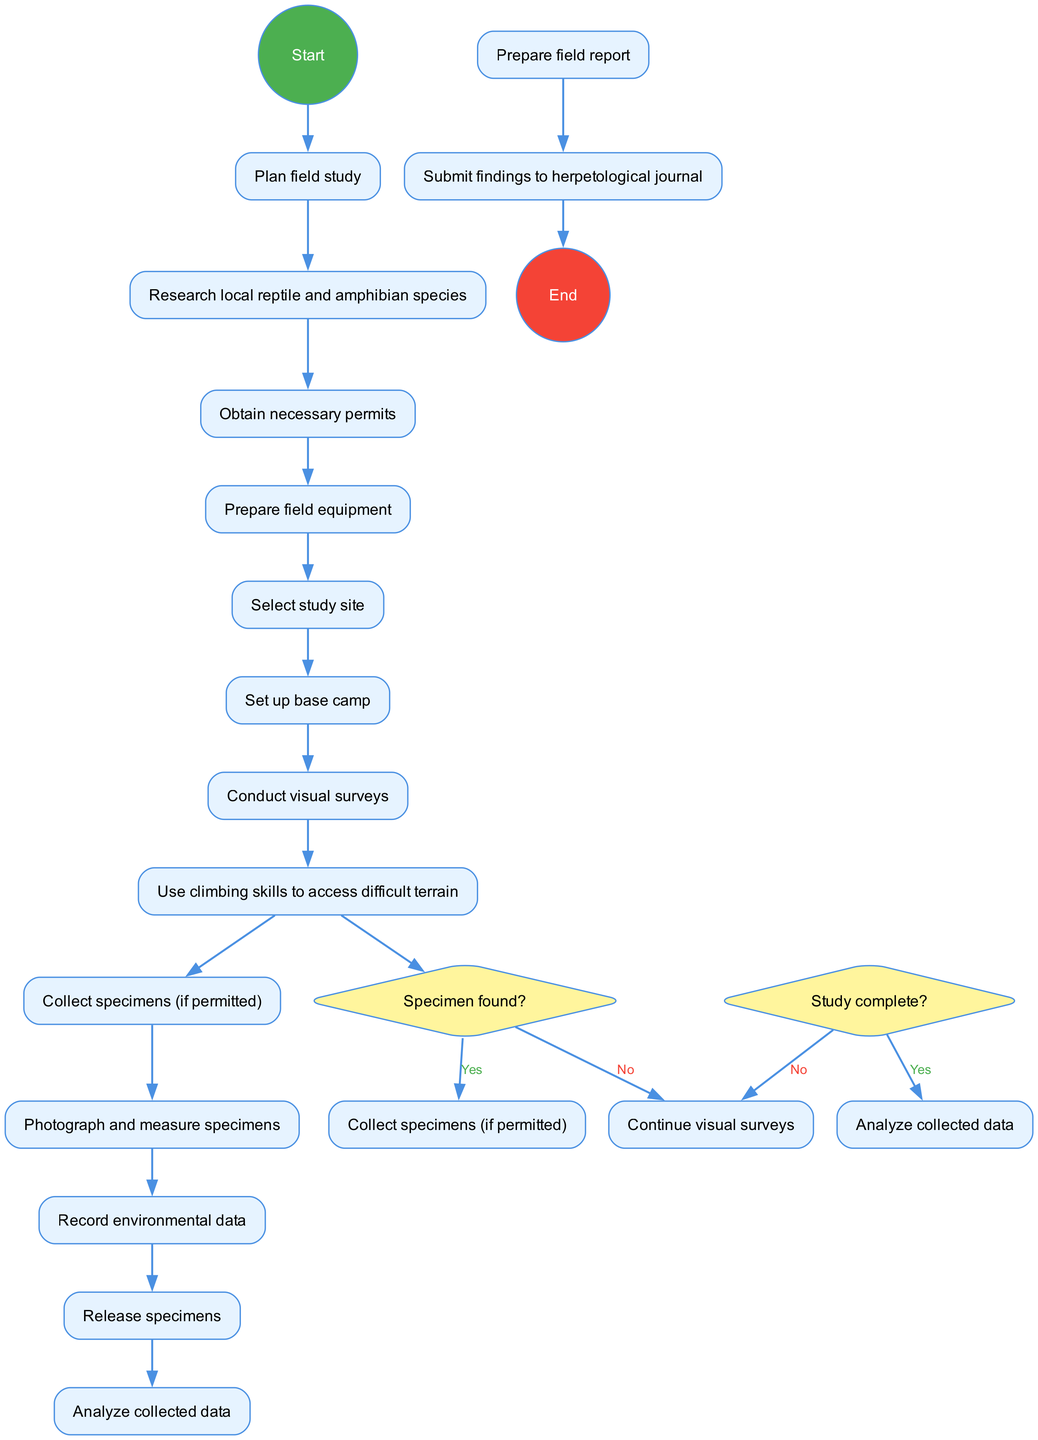What is the starting node of the diagram? The starting node, which denotes the beginning of the activity, is labeled "Plan field study." This information can be easily found at the top section of the diagram before any activities begin.
Answer: Plan field study How many activities are listed in the diagram? The diagram contains a total of 13 activities that outline various tasks involved in the herpetological field study. This is determined by counting every unique activity listed in the provided activities section.
Answer: 13 What are the options presented in the decision node "Specimen found?" The decision node "Specimen found?" presents two options: "Collect specimens (if permitted)" for the "Yes" path and "Continue visual surveys" for the "No" path. This can be verified directly from the decision node in the diagram where these pathways branch.
Answer: Collect specimens (if permitted), Continue visual surveys What is the final action in the diagram before ending? The last action before reaching the end node is "Prepare field report." This is identified by tracing the flow through the activities down to the very last one before the terminal point.
Answer: Prepare field report If a specimen is found, what is the next activity after collection? If a specimen is found and collected (given it’s permitted), the next activity is "Photograph and measure specimens." This sequence is found in the diagram by following the "Yes" path from the decision node "Specimen found?"
Answer: Photograph and measure specimens Which activity requires climbing skills? The activity that requires climbing skills is labeled "Use climbing skills to access difficult terrain." This can be seen in the activities flow where this specific task is associated with accessing challenging areas for specimen collection.
Answer: Use climbing skills to access difficult terrain What happens if the study is not complete? If the study is not complete, the path returns to "Continue visual surveys," indicating that more visual surveying will take place until the study is deemed complete. This is addressed in the decision node "Study complete?" within the diagram.
Answer: Continue visual surveys What is the last node of the diagram? The last node in the diagram is labeled "Submit findings to herpetological journal," which signifies the endpoint where results and findings are formally submitted for review or publication. This is located at the very bottom section of the diagram leading to the end node.
Answer: Submit findings to herpetological journal 